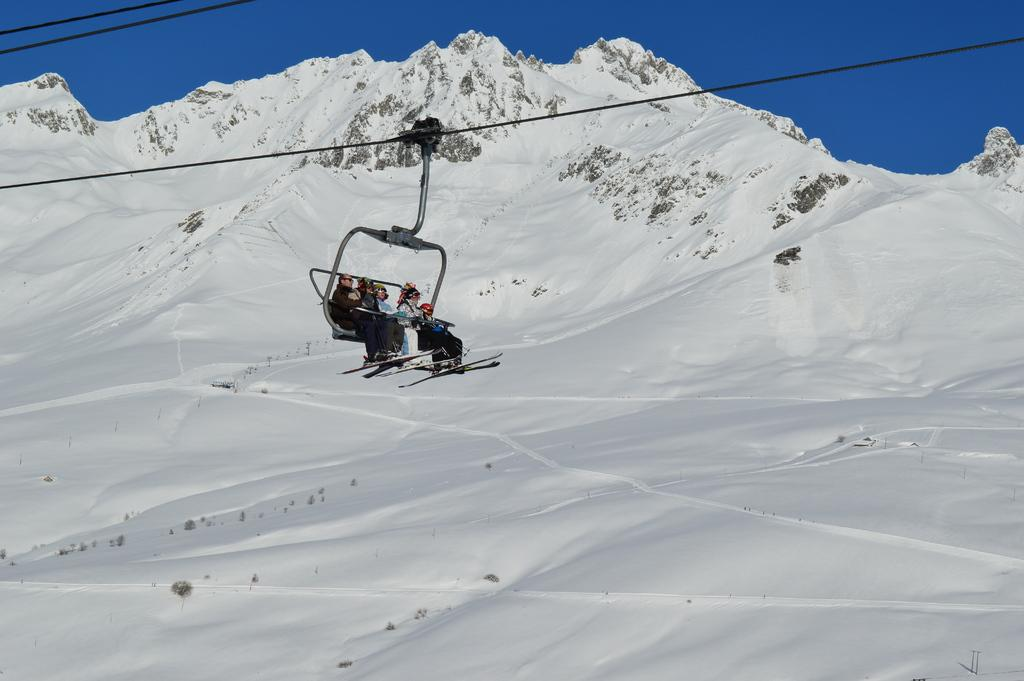What activity are the persons in the image participating in? The persons in the image are in a Ropeway ride. What can be seen at the top of the image? There is a sky at the top of the image. What geographical feature is in the middle of the image? There is a mountain in the middle of the image. What type of arch can be seen in the image? There is no arch present in the image. Can you tell me how many balls are visible in the image? There are no balls visible in the image. 